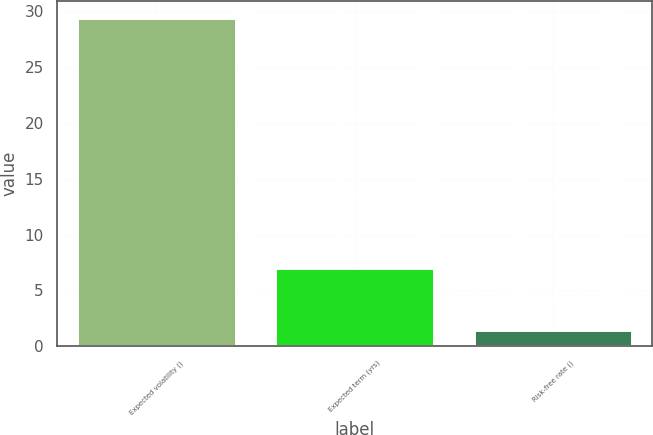Convert chart to OTSL. <chart><loc_0><loc_0><loc_500><loc_500><bar_chart><fcel>Expected volatility ()<fcel>Expected term (yrs)<fcel>Risk-free rate ()<nl><fcel>29.4<fcel>7<fcel>1.5<nl></chart> 